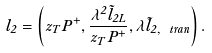<formula> <loc_0><loc_0><loc_500><loc_500>l _ { 2 } = \left ( z _ { T } P ^ { + } , \frac { \lambda ^ { 2 } \tilde { l } _ { 2 L } } { z _ { T } P ^ { + } } , \lambda \tilde { l } _ { 2 , \ t r a n } \right ) .</formula> 